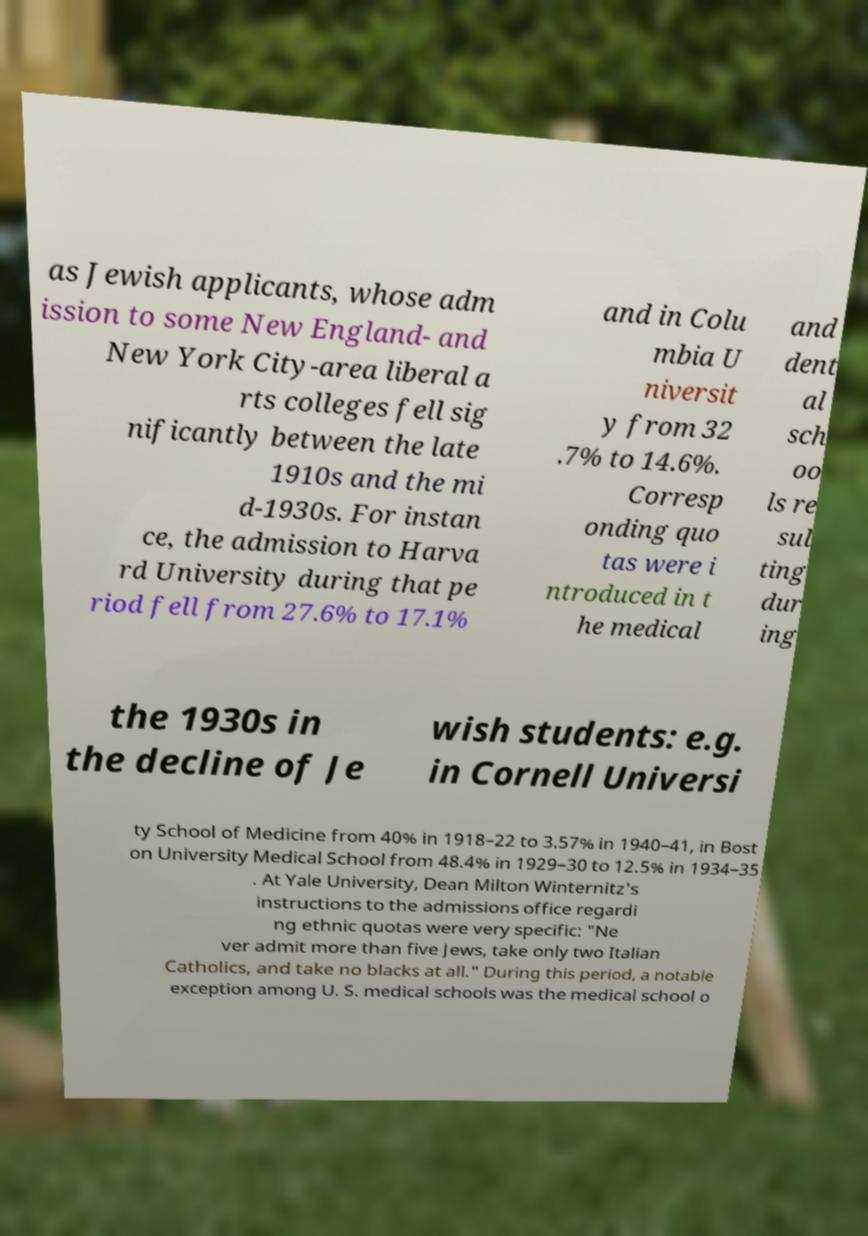Could you extract and type out the text from this image? as Jewish applicants, whose adm ission to some New England- and New York City-area liberal a rts colleges fell sig nificantly between the late 1910s and the mi d-1930s. For instan ce, the admission to Harva rd University during that pe riod fell from 27.6% to 17.1% and in Colu mbia U niversit y from 32 .7% to 14.6%. Corresp onding quo tas were i ntroduced in t he medical and dent al sch oo ls re sul ting dur ing the 1930s in the decline of Je wish students: e.g. in Cornell Universi ty School of Medicine from 40% in 1918–22 to 3.57% in 1940–41, in Bost on University Medical School from 48.4% in 1929–30 to 12.5% in 1934–35 . At Yale University, Dean Milton Winternitz's instructions to the admissions office regardi ng ethnic quotas were very specific: "Ne ver admit more than five Jews, take only two Italian Catholics, and take no blacks at all." During this period, a notable exception among U. S. medical schools was the medical school o 